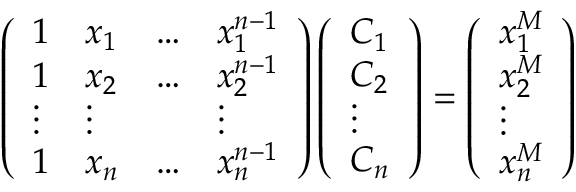Convert formula to latex. <formula><loc_0><loc_0><loc_500><loc_500>\left ( \begin{array} { l l l l } { 1 } & { x _ { 1 } } & { \dots } & { x _ { 1 } ^ { n - 1 } } \\ { 1 } & { x _ { 2 } } & { \dots } & { x _ { 2 } ^ { n - 1 } } \\ { \vdots } & { \vdots } & & { \vdots } \\ { 1 } & { x _ { n } } & { \dots } & { x _ { n } ^ { n - 1 } } \end{array} \right ) \left ( \begin{array} { l } { C _ { 1 } } \\ { C _ { 2 } } \\ { \vdots } \\ { C _ { n } } \end{array} \right ) = \left ( \begin{array} { l } { x _ { 1 } ^ { M } } \\ { x _ { 2 } ^ { M } } \\ { \vdots } \\ { x _ { n } ^ { M } } \end{array} \right )</formula> 